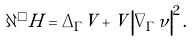Convert formula to latex. <formula><loc_0><loc_0><loc_500><loc_500>\partial ^ { \square } H = \Delta _ { \Gamma } V + V \left | \nabla _ { \Gamma } \nu \right | ^ { 2 } .</formula> 